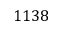Convert formula to latex. <formula><loc_0><loc_0><loc_500><loc_500>1 1 3 8</formula> 